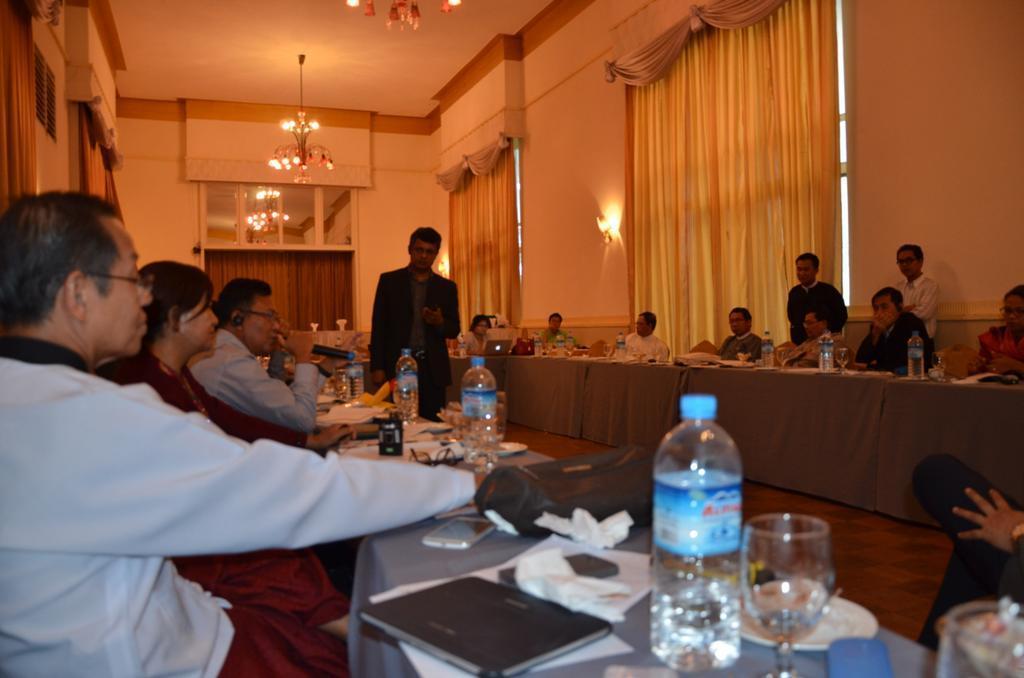Describe this image in one or two sentences. This is a dining hall in which some of the people are sitting around the table. There are some laptops, plates, bottles and glasses in front of them. One of the guy is walking in the middle. In the background we can observe curtains, lights and a wall here. 